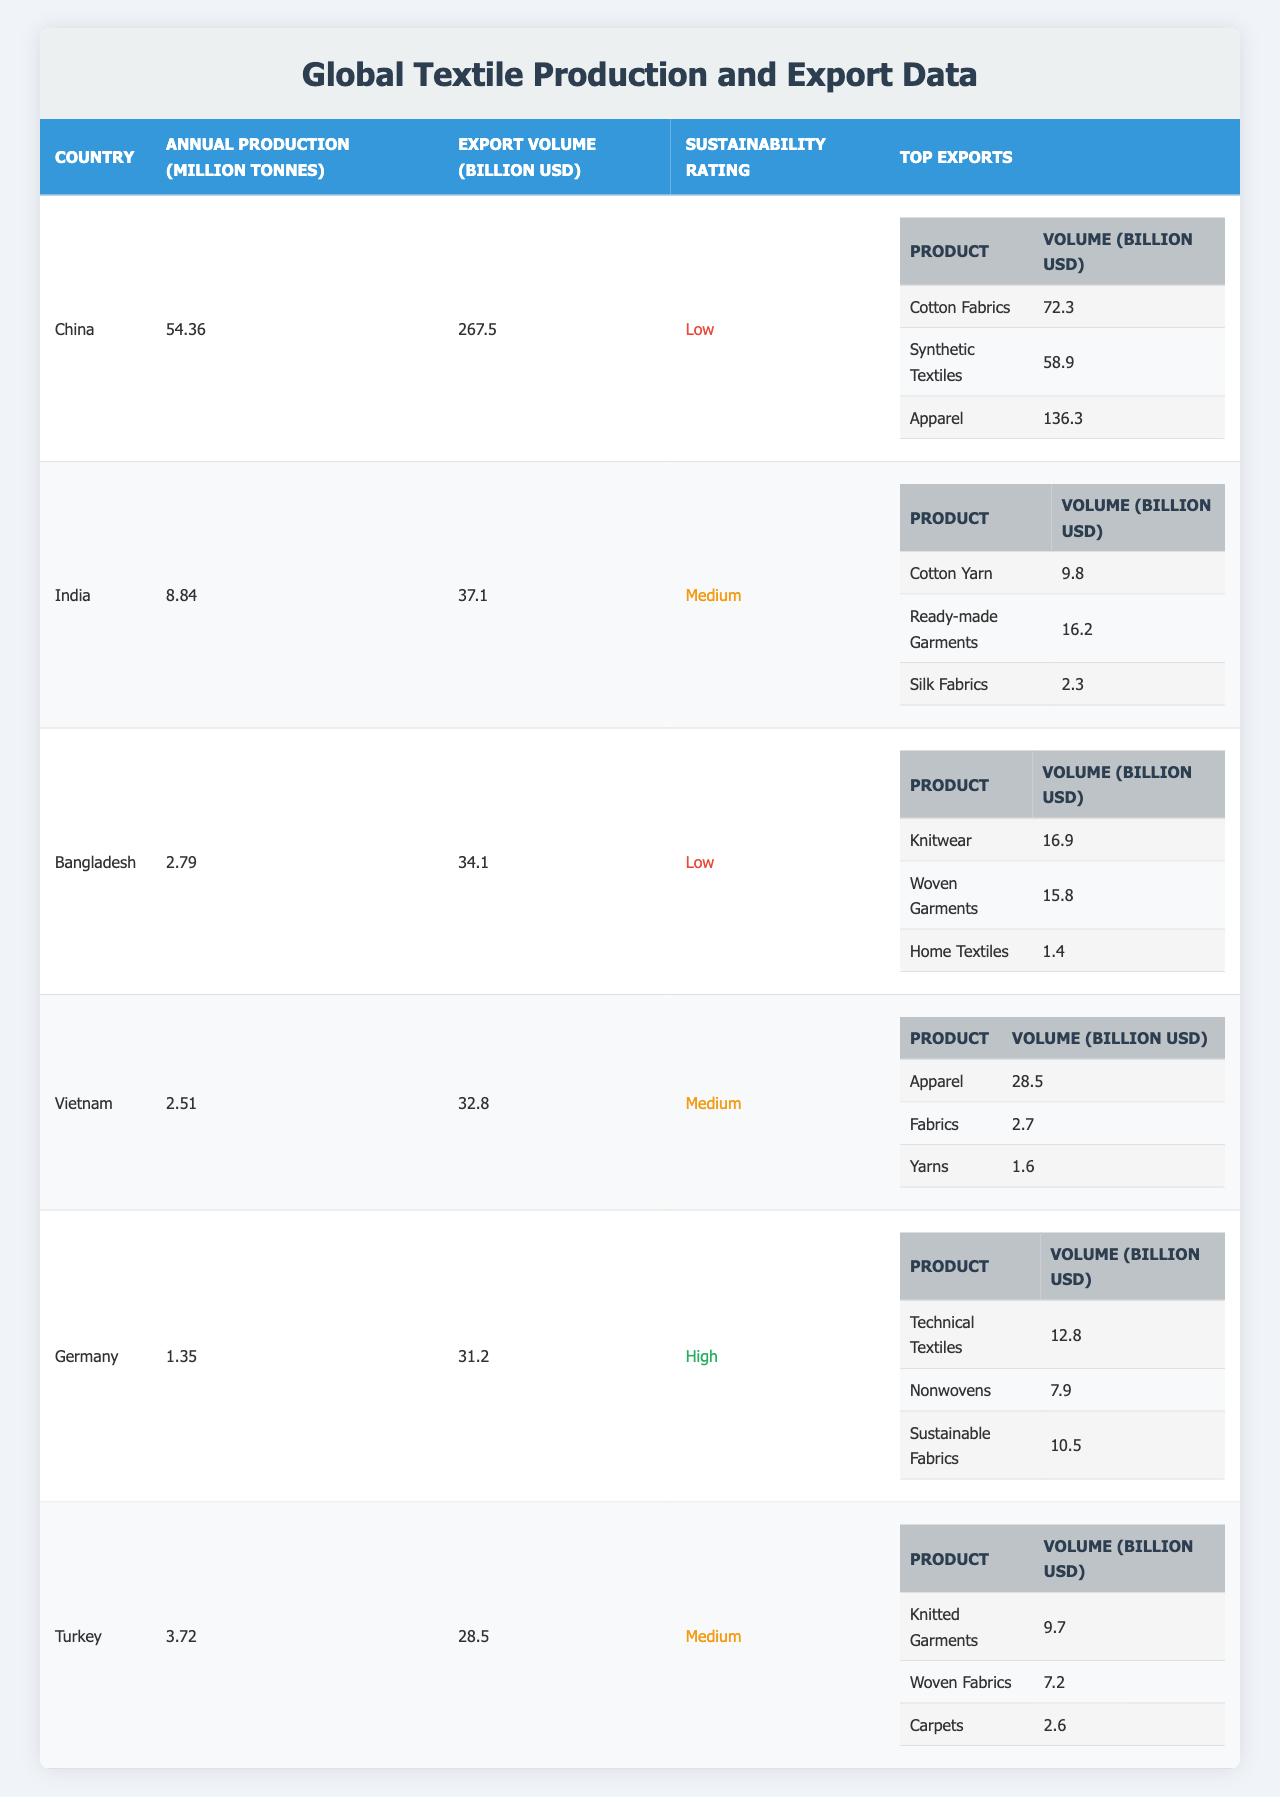What is the annual production of textiles in China? The table lists the annual production of textiles in China as 54.36 million tonnes.
Answer: 54.36 million tonnes Which country has the highest export volume? According to the table, China has the highest export volume at 267.5 billion USD.
Answer: China How many countries have a high sustainability rating? The table shows that only one country, Germany, has a high sustainability rating.
Answer: 1 What is the total export volume from India and Turkey combined? India's export volume is 37.1 billion USD, and Turkey's is 28.5 billion USD. Summing these gives 37.1 + 28.5 = 65.6 billion USD.
Answer: 65.6 billion USD Is the sustainability rating of Bangladesh medium? The table indicates that Bangladesh has a low sustainability rating, so the answer is no.
Answer: No What percentage of the annual textile production comes from the top three producing countries (China, India, and Bangladesh)? The total annual production from these countries is 54.36 + 8.84 + 2.79 = 65.99 million tonnes. Assuming the total production is the sum of all countries listed (70.41 million tonnes), the percentage can be calculated as (65.99 / 70.41) * 100 = approximately 93.7%.
Answer: 93.7% What is the total volume of cotton-related exports from India? In India, the top exports include Cotton Yarn (9.8 billion USD) and Ready-made Garments (16.2 billion USD), but Silk Fabrics is not cotton-related. Thus, total volume is 9.8 + 16.2 = 26 billion USD.
Answer: 26 billion USD Which country produces the least amount of textiles? The table shows that Bangladesh has the lowest annual production at 2.79 million tonnes.
Answer: Bangladesh Are all countries with low sustainability ratings also the largest producers? The data shows that while China and Bangladesh have low sustainability ratings, they do not correlate with having the largest production without considering India. Thus, the answer is no.
Answer: No What are the top export products from Vietnam? Vietnam's top exports include Apparel (28.5 billion USD), Fabrics (2.7 billion USD), and Yarns (1.6 billion USD).
Answer: Apparel, Fabrics, Yarns How does the total export volume of Germany compare with that of Vietnam? Germany has an export volume of 31.2 billion USD, while Vietnam has 32.8 billion USD. Since 32.8 is greater than 31.2, Vietnam's export volume is higher.
Answer: Vietnam's export volume is higher 